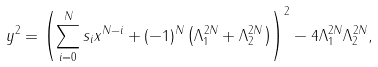<formula> <loc_0><loc_0><loc_500><loc_500>y ^ { 2 } = \left ( \sum _ { i = 0 } ^ { N } s _ { i } x ^ { N - i } + ( - 1 ) ^ { N } \left ( \Lambda _ { 1 } ^ { 2 N } + \Lambda _ { 2 } ^ { 2 N } \right ) \right ) ^ { 2 } - 4 \Lambda _ { 1 } ^ { 2 N } \Lambda _ { 2 } ^ { 2 N } ,</formula> 